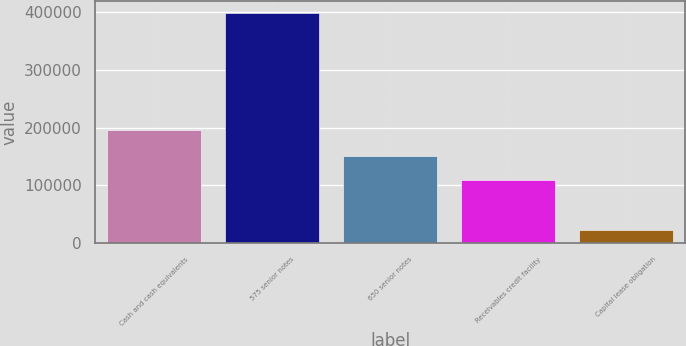<chart> <loc_0><loc_0><loc_500><loc_500><bar_chart><fcel>Cash and cash equivalents<fcel>575 senior notes<fcel>650 senior notes<fcel>Receivables credit facility<fcel>Capital lease obligation<nl><fcel>196556<fcel>399143<fcel>149956<fcel>109000<fcel>22502<nl></chart> 